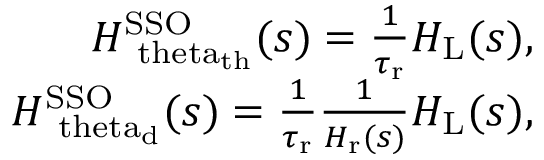Convert formula to latex. <formula><loc_0><loc_0><loc_500><loc_500>\begin{array} { r } { H _ { \ t h e t a _ { \mathrm { t h } } } ^ { S S O } ( s ) = \frac { 1 } { \tau _ { r } } H _ { L } ( s ) , } \\ { H _ { \ t h e t a _ { \mathrm { d } } } ^ { S S O } ( s ) = \frac { 1 } { \tau _ { r } } \frac { 1 } { H _ { r } ( s ) } H _ { L } ( s ) , } \end{array}</formula> 